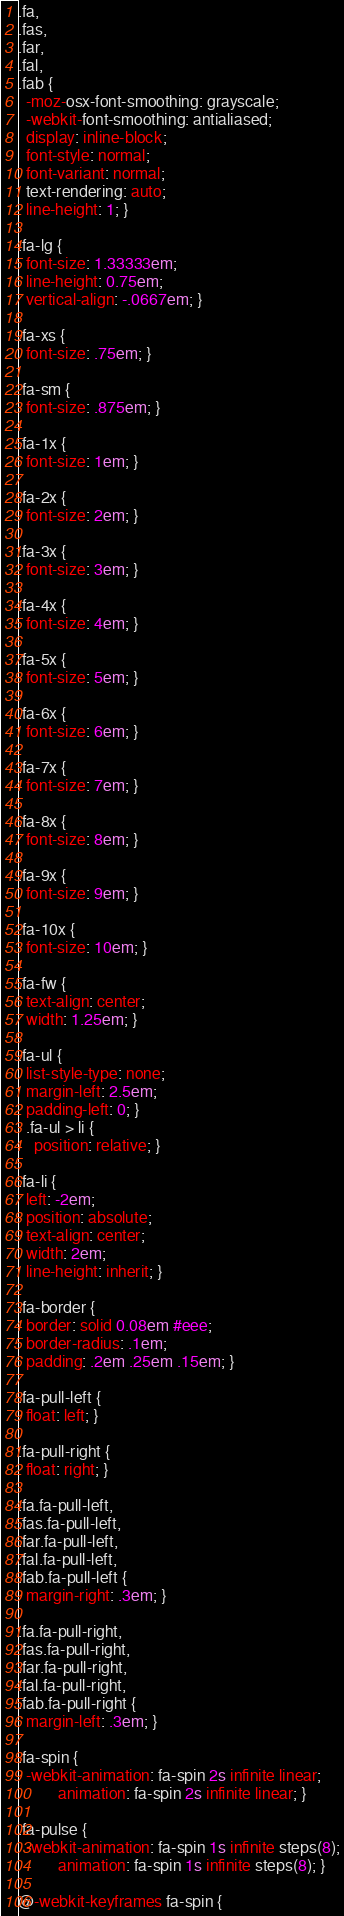<code> <loc_0><loc_0><loc_500><loc_500><_CSS_>.fa,
.fas,
.far,
.fal,
.fab {
  -moz-osx-font-smoothing: grayscale;
  -webkit-font-smoothing: antialiased;
  display: inline-block;
  font-style: normal;
  font-variant: normal;
  text-rendering: auto;
  line-height: 1; }

.fa-lg {
  font-size: 1.33333em;
  line-height: 0.75em;
  vertical-align: -.0667em; }

.fa-xs {
  font-size: .75em; }

.fa-sm {
  font-size: .875em; }

.fa-1x {
  font-size: 1em; }

.fa-2x {
  font-size: 2em; }

.fa-3x {
  font-size: 3em; }

.fa-4x {
  font-size: 4em; }

.fa-5x {
  font-size: 5em; }

.fa-6x {
  font-size: 6em; }

.fa-7x {
  font-size: 7em; }

.fa-8x {
  font-size: 8em; }

.fa-9x {
  font-size: 9em; }

.fa-10x {
  font-size: 10em; }

.fa-fw {
  text-align: center;
  width: 1.25em; }

.fa-ul {
  list-style-type: none;
  margin-left: 2.5em;
  padding-left: 0; }
  .fa-ul > li {
    position: relative; }

.fa-li {
  left: -2em;
  position: absolute;
  text-align: center;
  width: 2em;
  line-height: inherit; }

.fa-border {
  border: solid 0.08em #eee;
  border-radius: .1em;
  padding: .2em .25em .15em; }

.fa-pull-left {
  float: left; }

.fa-pull-right {
  float: right; }

.fa.fa-pull-left,
.fas.fa-pull-left,
.far.fa-pull-left,
.fal.fa-pull-left,
.fab.fa-pull-left {
  margin-right: .3em; }

.fa.fa-pull-right,
.fas.fa-pull-right,
.far.fa-pull-right,
.fal.fa-pull-right,
.fab.fa-pull-right {
  margin-left: .3em; }

.fa-spin {
  -webkit-animation: fa-spin 2s infinite linear;
          animation: fa-spin 2s infinite linear; }

.fa-pulse {
  -webkit-animation: fa-spin 1s infinite steps(8);
          animation: fa-spin 1s infinite steps(8); }

@-webkit-keyframes fa-spin {</code> 